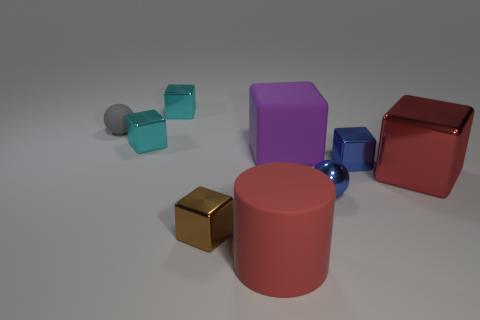Subtract all metal blocks. How many blocks are left? 1 Add 1 big purple metallic objects. How many objects exist? 10 Subtract all cyan balls. How many cyan cubes are left? 2 Subtract all blue spheres. How many spheres are left? 1 Subtract all blocks. How many objects are left? 3 Add 1 small objects. How many small objects are left? 7 Add 5 gray objects. How many gray objects exist? 6 Subtract 0 yellow cylinders. How many objects are left? 9 Subtract 5 cubes. How many cubes are left? 1 Subtract all purple blocks. Subtract all gray cylinders. How many blocks are left? 5 